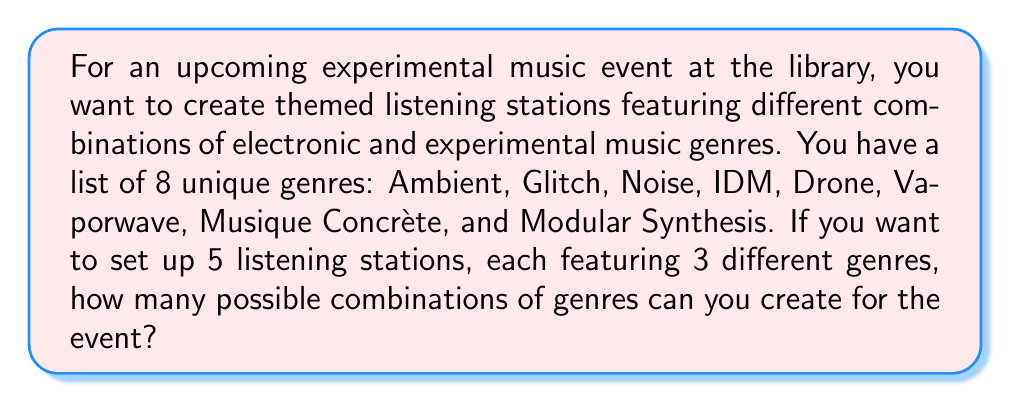What is the answer to this math problem? To solve this problem, we need to use the combination formula. We are selecting 3 genres out of 8 for each listening station, and the order doesn't matter (e.g., a station with Ambient, Glitch, and Noise is considered the same as one with Glitch, Noise, and Ambient).

The formula for combinations is:

$$ C(n,r) = \frac{n!}{r!(n-r)!} $$

Where:
$n$ is the total number of items to choose from (in this case, 8 genres)
$r$ is the number of items being chosen (in this case, 3 genres per station)

Plugging in our values:

$$ C(8,3) = \frac{8!}{3!(8-3)!} = \frac{8!}{3!5!} $$

Expanding this:

$$ \frac{8 \times 7 \times 6 \times 5!}{(3 \times 2 \times 1) \times 5!} $$

The $5!$ cancels out in the numerator and denominator:

$$ \frac{8 \times 7 \times 6}{3 \times 2 \times 1} = \frac{336}{6} = 56 $$

Therefore, there are 56 possible combinations of 3 genres that can be created from the list of 8 genres.

Since we want to set up 5 listening stations, and each station's combination is independent of the others (we can reuse genres across stations), the total number of possible combinations remains 56. Each of the 5 stations can be any one of these 56 combinations.
Answer: 56 possible combinations 